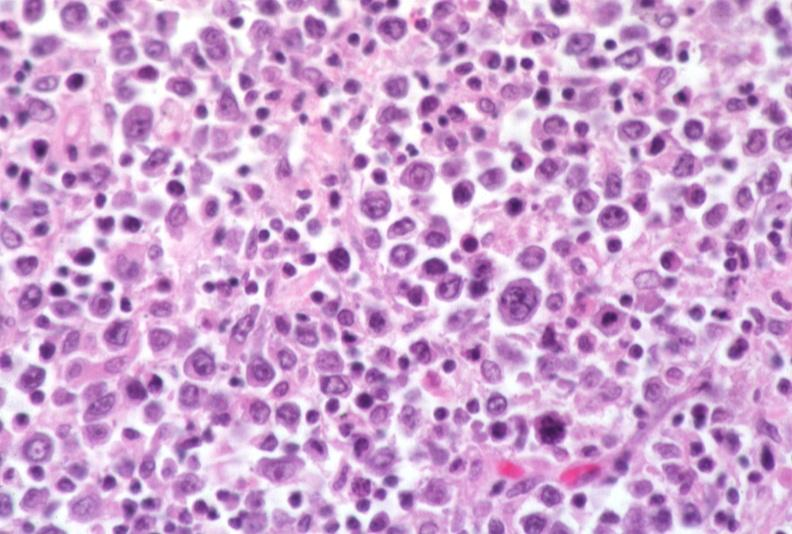what does this image show?
Answer the question using a single word or phrase. Lymph node 